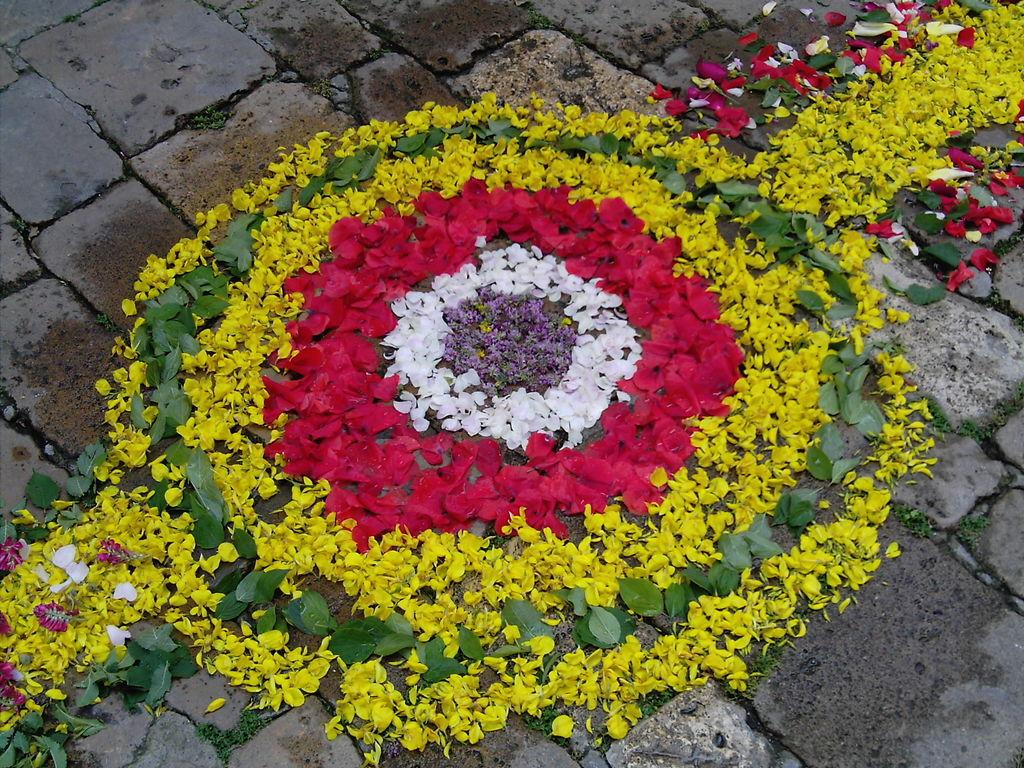What type of plants can be seen in the picture? There are flowers in the picture. Can you describe the appearance of the flowers? The flowers are in different colors. Where are the flowers located in the picture? The flowers are placed on the ground. What type of nut can be seen falling from the tree in the picture? There is no tree or nut present in the image; it only features flowers placed on the ground. 